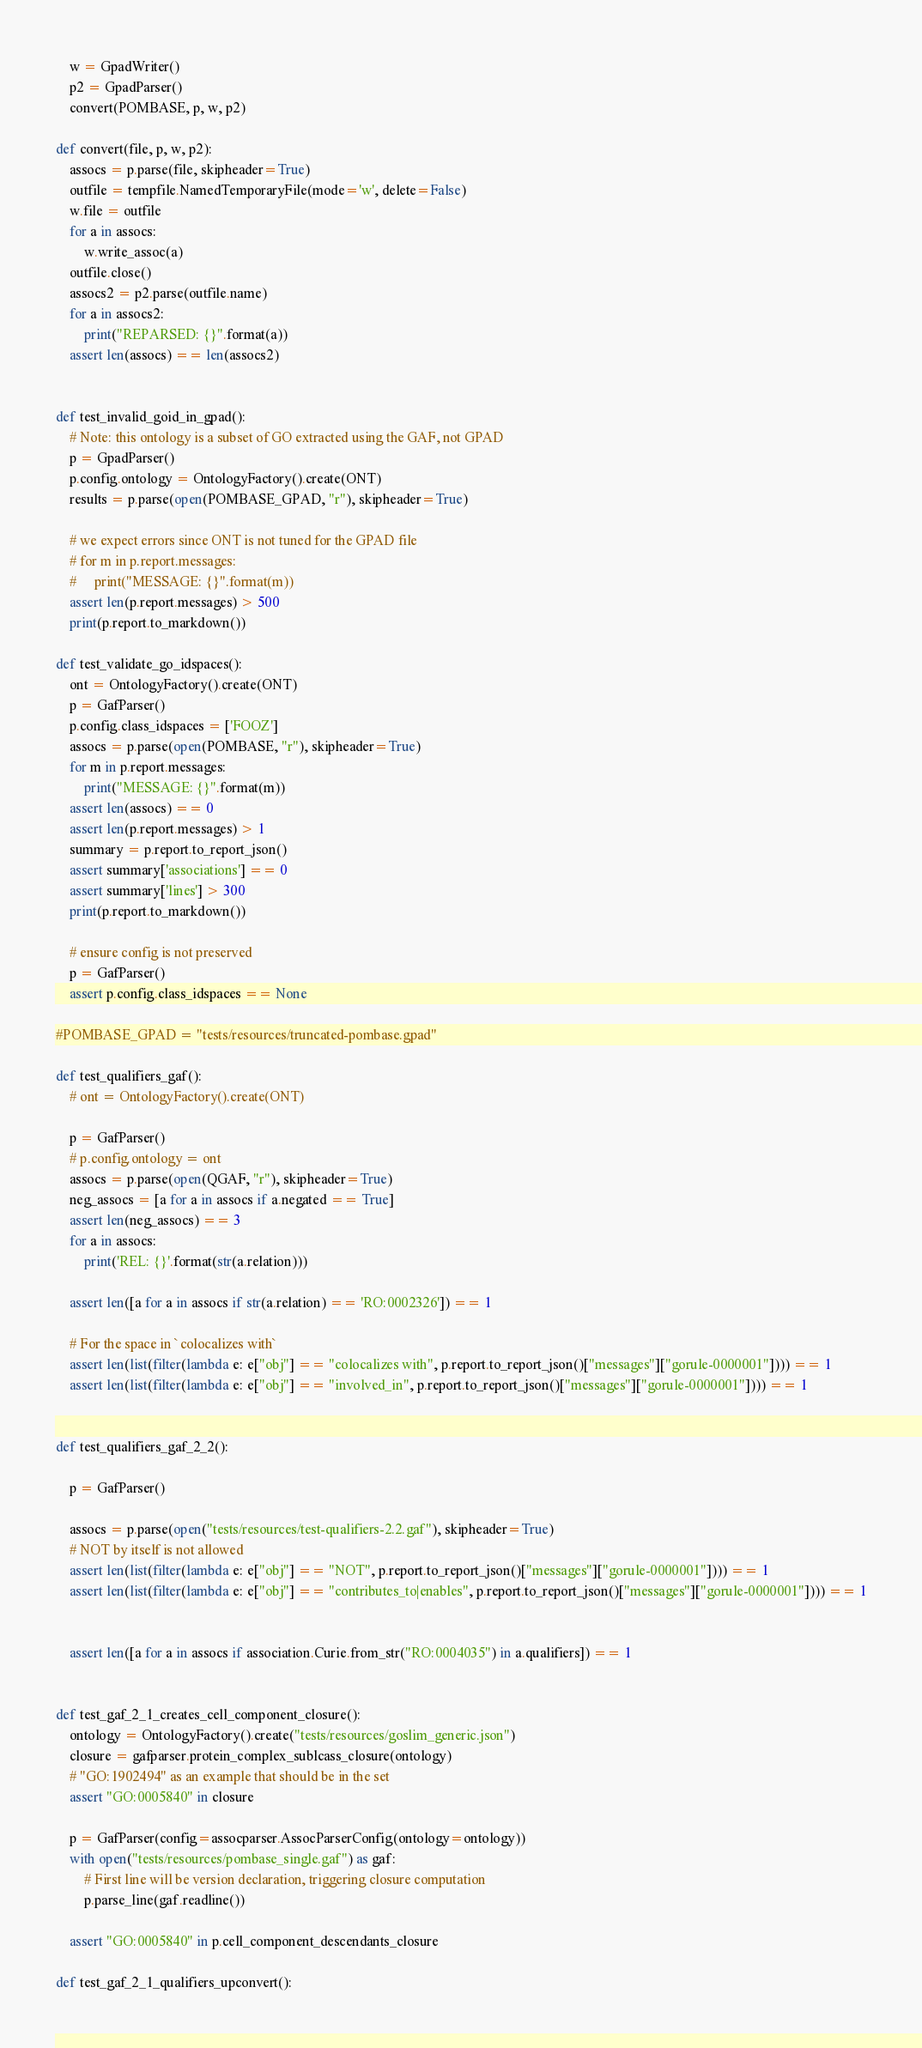<code> <loc_0><loc_0><loc_500><loc_500><_Python_>    w = GpadWriter()
    p2 = GpadParser()
    convert(POMBASE, p, w, p2)

def convert(file, p, w, p2):
    assocs = p.parse(file, skipheader=True)
    outfile = tempfile.NamedTemporaryFile(mode='w', delete=False)
    w.file = outfile
    for a in assocs:
        w.write_assoc(a)
    outfile.close()
    assocs2 = p2.parse(outfile.name)
    for a in assocs2:
        print("REPARSED: {}".format(a))
    assert len(assocs) == len(assocs2)


def test_invalid_goid_in_gpad():
    # Note: this ontology is a subset of GO extracted using the GAF, not GPAD
    p = GpadParser()
    p.config.ontology = OntologyFactory().create(ONT)
    results = p.parse(open(POMBASE_GPAD, "r"), skipheader=True)

    # we expect errors since ONT is not tuned for the GPAD file
    # for m in p.report.messages:
    #     print("MESSAGE: {}".format(m))
    assert len(p.report.messages) > 500
    print(p.report.to_markdown())

def test_validate_go_idspaces():
    ont = OntologyFactory().create(ONT)
    p = GafParser()
    p.config.class_idspaces = ['FOOZ']
    assocs = p.parse(open(POMBASE, "r"), skipheader=True)
    for m in p.report.messages:
        print("MESSAGE: {}".format(m))
    assert len(assocs) == 0
    assert len(p.report.messages) > 1
    summary = p.report.to_report_json()
    assert summary['associations'] == 0
    assert summary['lines'] > 300
    print(p.report.to_markdown())

    # ensure config is not preserved
    p = GafParser()
    assert p.config.class_idspaces == None

#POMBASE_GPAD = "tests/resources/truncated-pombase.gpad"

def test_qualifiers_gaf():
    # ont = OntologyFactory().create(ONT)

    p = GafParser()
    # p.config.ontology = ont
    assocs = p.parse(open(QGAF, "r"), skipheader=True)
    neg_assocs = [a for a in assocs if a.negated == True]
    assert len(neg_assocs) == 3
    for a in assocs:
        print('REL: {}'.format(str(a.relation)))

    assert len([a for a in assocs if str(a.relation) == 'RO:0002326']) == 1

    # For the space in `colocalizes with`
    assert len(list(filter(lambda e: e["obj"] == "colocalizes with", p.report.to_report_json()["messages"]["gorule-0000001"]))) == 1
    assert len(list(filter(lambda e: e["obj"] == "involved_in", p.report.to_report_json()["messages"]["gorule-0000001"]))) == 1


def test_qualifiers_gaf_2_2():

    p = GafParser()

    assocs = p.parse(open("tests/resources/test-qualifiers-2.2.gaf"), skipheader=True)
    # NOT by itself is not allowed
    assert len(list(filter(lambda e: e["obj"] == "NOT", p.report.to_report_json()["messages"]["gorule-0000001"]))) == 1
    assert len(list(filter(lambda e: e["obj"] == "contributes_to|enables", p.report.to_report_json()["messages"]["gorule-0000001"]))) == 1


    assert len([a for a in assocs if association.Curie.from_str("RO:0004035") in a.qualifiers]) == 1


def test_gaf_2_1_creates_cell_component_closure():
    ontology = OntologyFactory().create("tests/resources/goslim_generic.json")
    closure = gafparser.protein_complex_sublcass_closure(ontology)
    # "GO:1902494" as an example that should be in the set
    assert "GO:0005840" in closure

    p = GafParser(config=assocparser.AssocParserConfig(ontology=ontology))
    with open("tests/resources/pombase_single.gaf") as gaf:
        # First line will be version declaration, triggering closure computation
        p.parse_line(gaf.readline())

    assert "GO:0005840" in p.cell_component_descendants_closure

def test_gaf_2_1_qualifiers_upconvert():</code> 